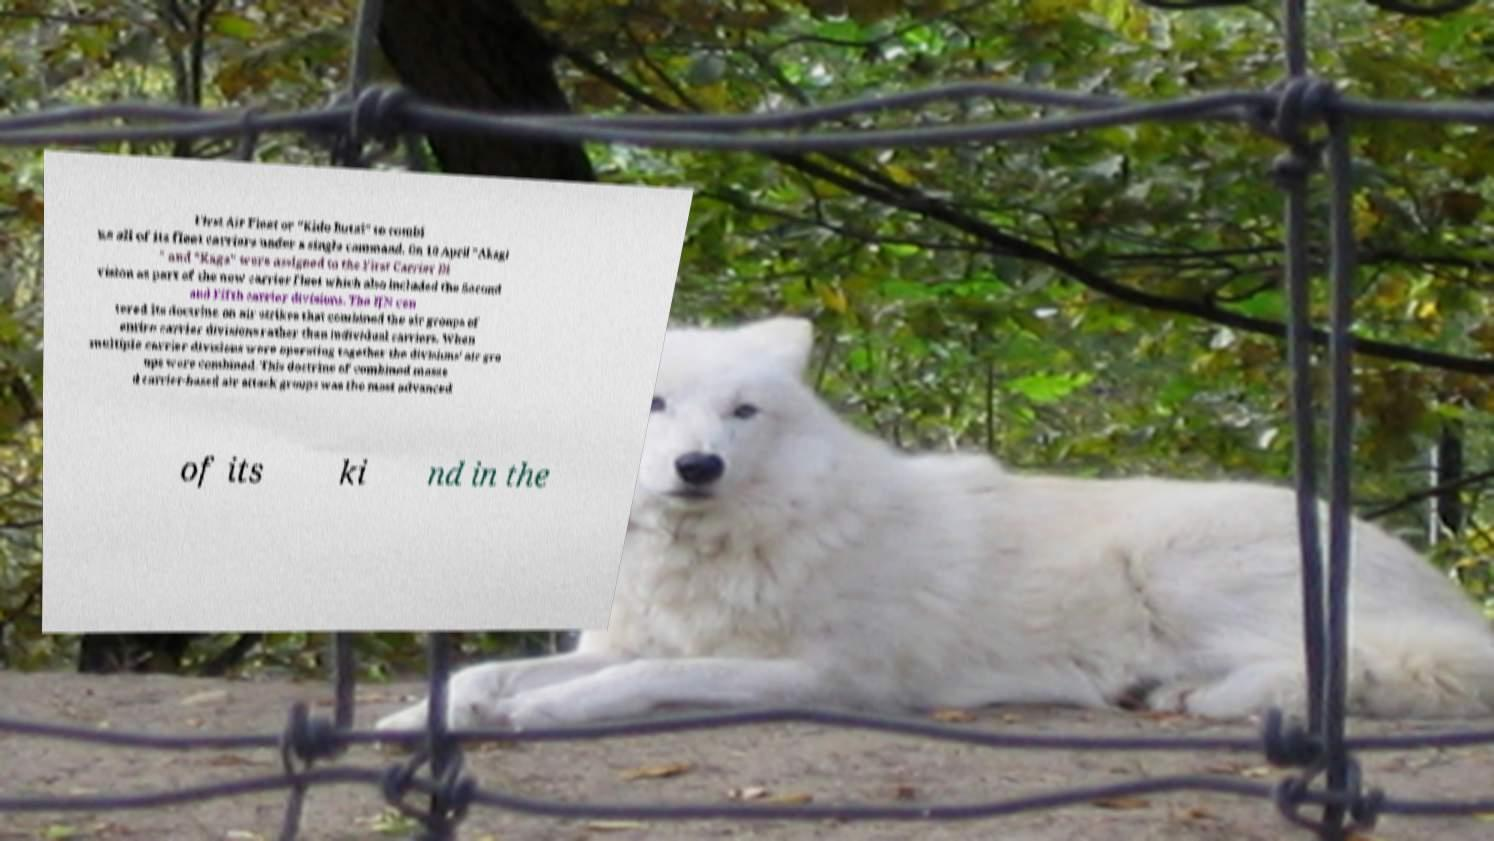Please identify and transcribe the text found in this image. First Air Fleet or "Kido Butai" to combi ne all of its fleet carriers under a single command. On 10 April "Akagi " and "Kaga" were assigned to the First Carrier Di vision as part of the new carrier fleet which also included the Second and Fifth carrier divisions. The IJN cen tered its doctrine on air strikes that combined the air groups of entire carrier divisions rather than individual carriers. When multiple carrier divisions were operating together the divisions' air gro ups were combined. This doctrine of combined masse d carrier-based air attack groups was the most advanced of its ki nd in the 